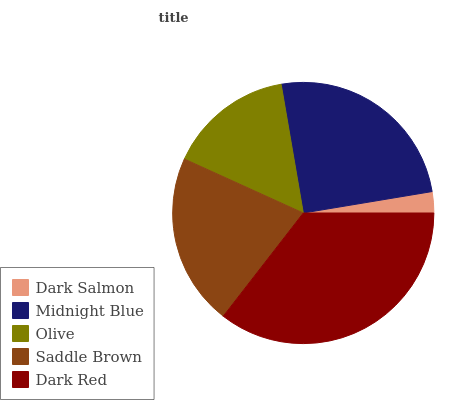Is Dark Salmon the minimum?
Answer yes or no. Yes. Is Dark Red the maximum?
Answer yes or no. Yes. Is Midnight Blue the minimum?
Answer yes or no. No. Is Midnight Blue the maximum?
Answer yes or no. No. Is Midnight Blue greater than Dark Salmon?
Answer yes or no. Yes. Is Dark Salmon less than Midnight Blue?
Answer yes or no. Yes. Is Dark Salmon greater than Midnight Blue?
Answer yes or no. No. Is Midnight Blue less than Dark Salmon?
Answer yes or no. No. Is Saddle Brown the high median?
Answer yes or no. Yes. Is Saddle Brown the low median?
Answer yes or no. Yes. Is Dark Salmon the high median?
Answer yes or no. No. Is Dark Red the low median?
Answer yes or no. No. 